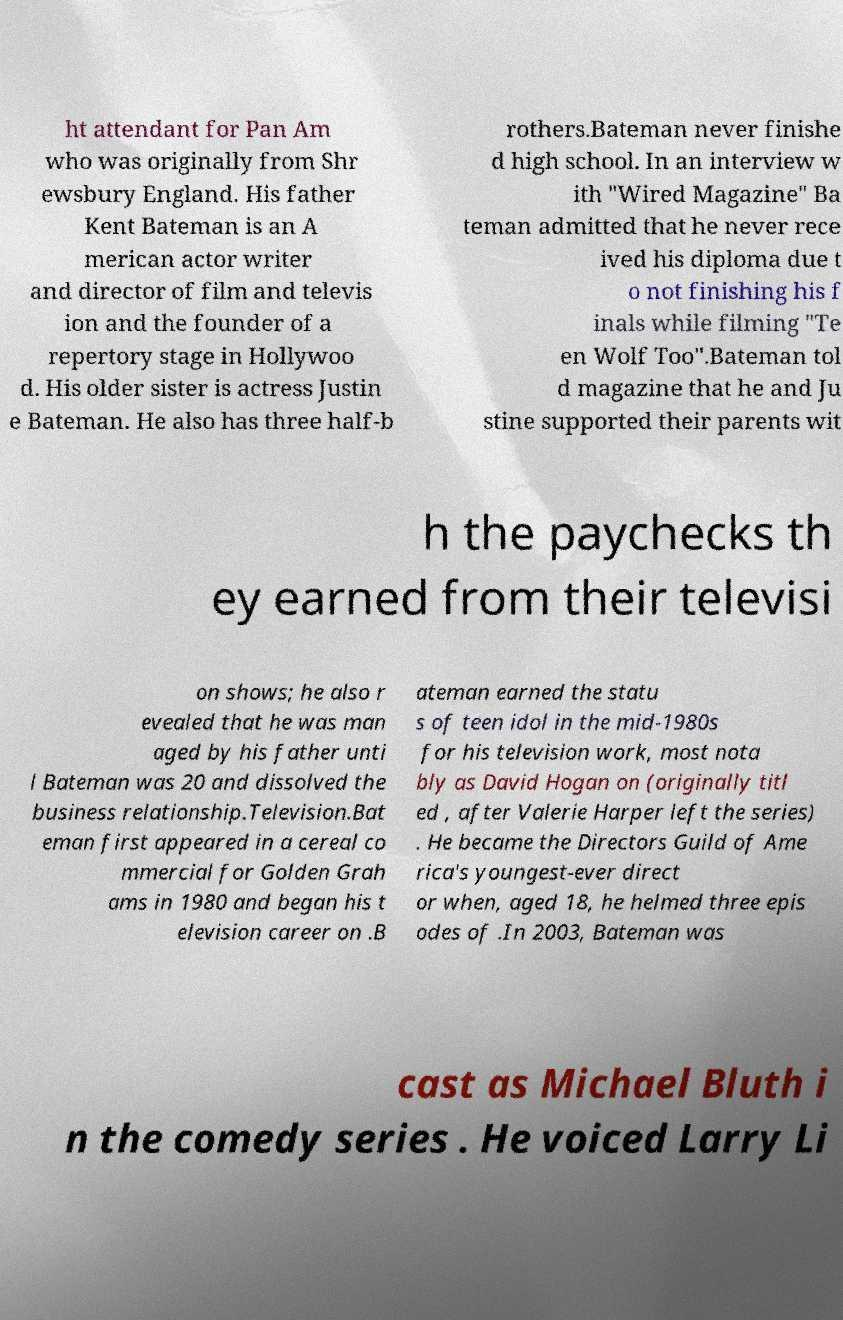I need the written content from this picture converted into text. Can you do that? ht attendant for Pan Am who was originally from Shr ewsbury England. His father Kent Bateman is an A merican actor writer and director of film and televis ion and the founder of a repertory stage in Hollywoo d. His older sister is actress Justin e Bateman. He also has three half-b rothers.Bateman never finishe d high school. In an interview w ith "Wired Magazine" Ba teman admitted that he never rece ived his diploma due t o not finishing his f inals while filming "Te en Wolf Too".Bateman tol d magazine that he and Ju stine supported their parents wit h the paychecks th ey earned from their televisi on shows; he also r evealed that he was man aged by his father unti l Bateman was 20 and dissolved the business relationship.Television.Bat eman first appeared in a cereal co mmercial for Golden Grah ams in 1980 and began his t elevision career on .B ateman earned the statu s of teen idol in the mid-1980s for his television work, most nota bly as David Hogan on (originally titl ed , after Valerie Harper left the series) . He became the Directors Guild of Ame rica's youngest-ever direct or when, aged 18, he helmed three epis odes of .In 2003, Bateman was cast as Michael Bluth i n the comedy series . He voiced Larry Li 